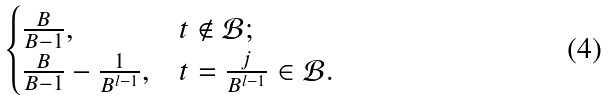<formula> <loc_0><loc_0><loc_500><loc_500>\begin{cases} \frac { B } { B - 1 } , & t \notin \mathcal { B } ; \\ \frac { B } { B - 1 } - \frac { 1 } { B ^ { l - 1 } } , & t = \frac { j } { B ^ { l - 1 } } \in \mathcal { B } . \end{cases}</formula> 